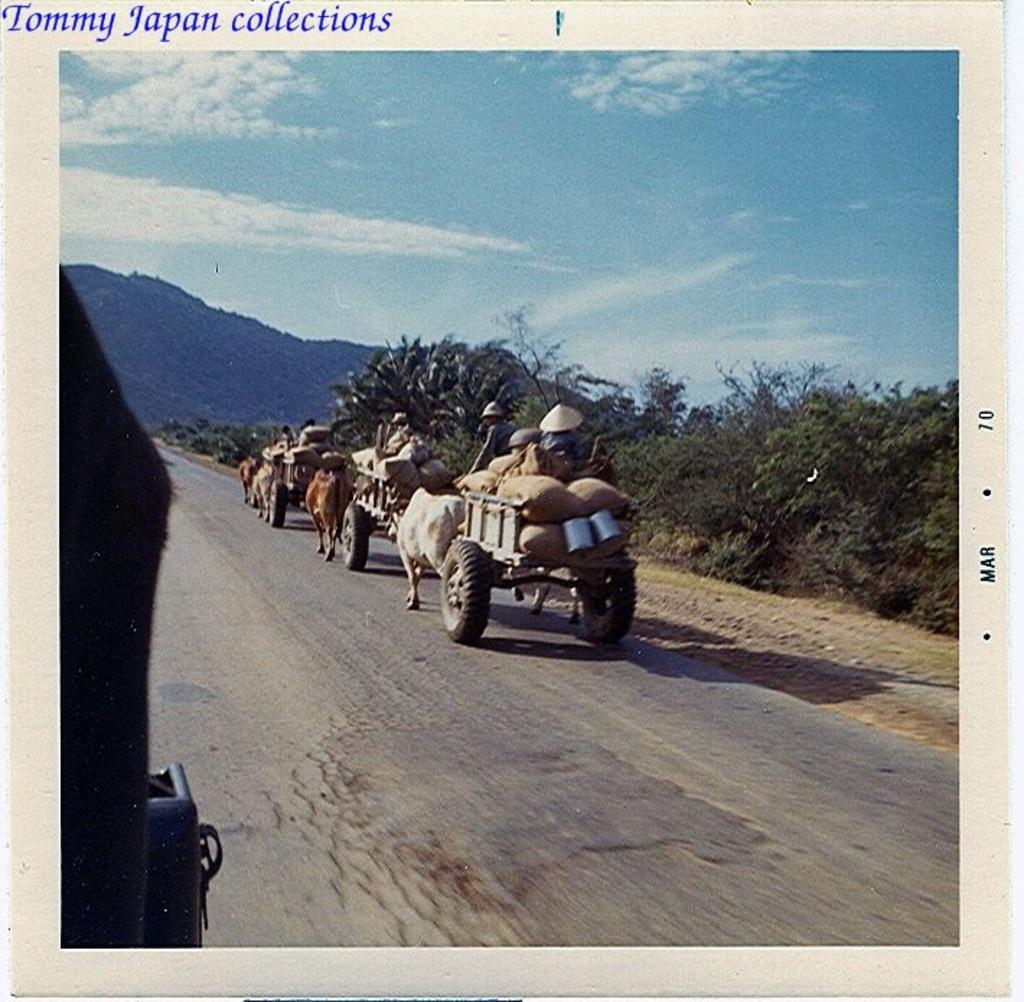How would you summarize this image in a sentence or two? This image is clicked outside. There are trees in the middle. There are carts in the middle. There is sky at the top. 